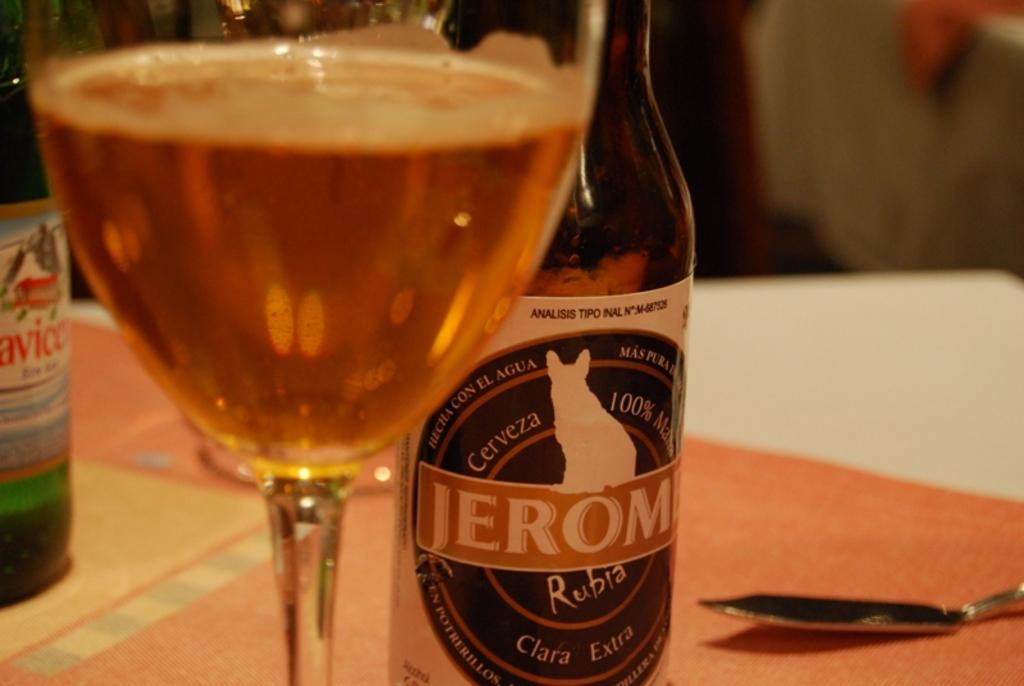<image>
Summarize the visual content of the image. A bottle of Jerome next to a full glass. 